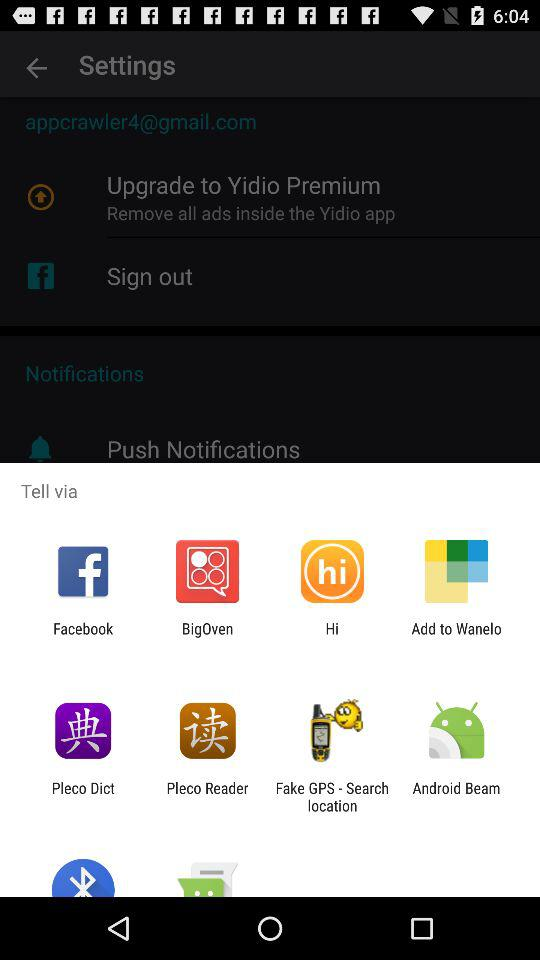Via which application can we tell? You can tell via "Facebook", "BigOven", "Hi", "Add to Wanelo", "Pleco Dict", "Pleco Reader", "Fake GPS - Search location" and "Android Beam". 